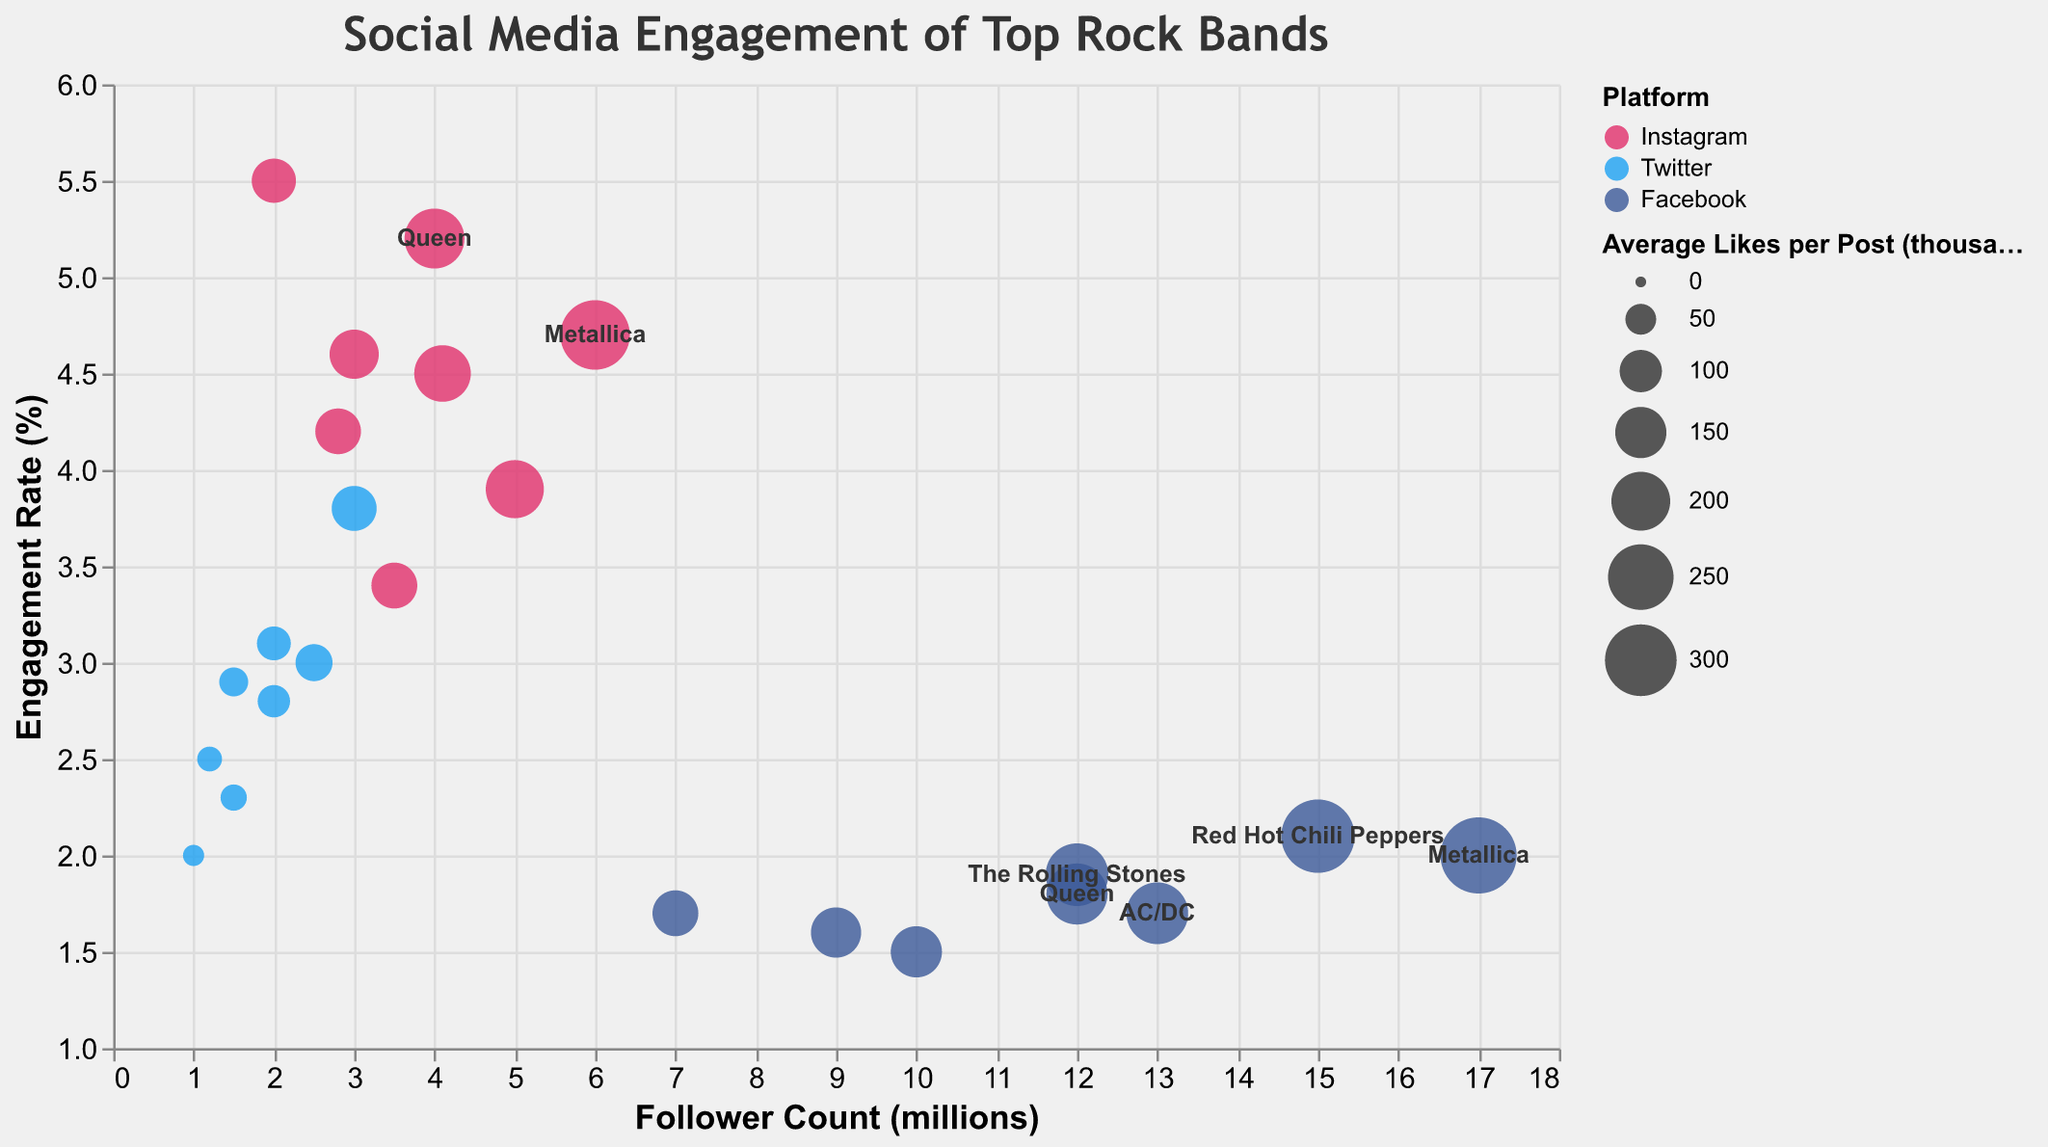What's the title of the chart? The title is displayed at the top of the chart in a prominent position.
Answer: Social Media Engagement of Top Rock Bands Which band/artist has the highest engagement rate on Instagram? Look at the data points along the y-axis representing 'Engagement Rate (%)' and the color representing Instagram. The highest point is for Led Zeppelin.
Answer: Led Zeppelin How many platforms are represented in the figure? The color legend indicates the categories represented for the platforms. There are three distinct colors.
Answer: 3 Which band/artist has the largest bubble on Facebook and what does it mean? The size of the bubbles represents 'Average Likes per Post (thousands)'. Look at the largest bubble colored for Facebook. It is Metallica, indicating it has the highest average likes per post on Facebook.
Answer: Metallica Compare the engagement rates of Queen and Metallica on Twitter. Who has a higher rate? Find the data points for Queen and Metallica on Twitter and compare their positions on the y-axis. Metallica is higher.
Answer: Metallica Which platform has the overall highest engagement rates for bands/artists? Observe the highest points along the y-axis and note the corresponding colors. Most of the highest points are Instagram.
Answer: Instagram Which band/artist has a higher average likes per post: Nirvana on Instagram or Red Hot Chili Peppers on Instagram? Compare the sizes of the bubbles for Nirvana and Red Hot Chili Peppers on Instagram. Red Hot Chili Peppers has a larger bubble size.
Answer: Red Hot Chili Peppers Which band/artist has the highest follower count on Facebook and what is their engagement rate? Look at the bubbles along the x-axis and find the highest point for Facebook, then see its y-coordinate. Metallica has the highest follower count with an engagement rate of 2.
Answer: Metallica, 2% Compare the average likes per post of Foo Fighters on Twitter and Instagram. Which platform has higher average likes for them? Observe and compare the sizes of Foo Fighters' bubbles on Twitter and Instagram. Instagram has a larger bubble size.
Answer: Instagram Which band/artist has the smallest bubble on Twitter and what does it signify? Find the smallest bubble colored for Twitter. It represents the lowest average likes per post, which is Led Zeppelin.
Answer: Led Zeppelin 